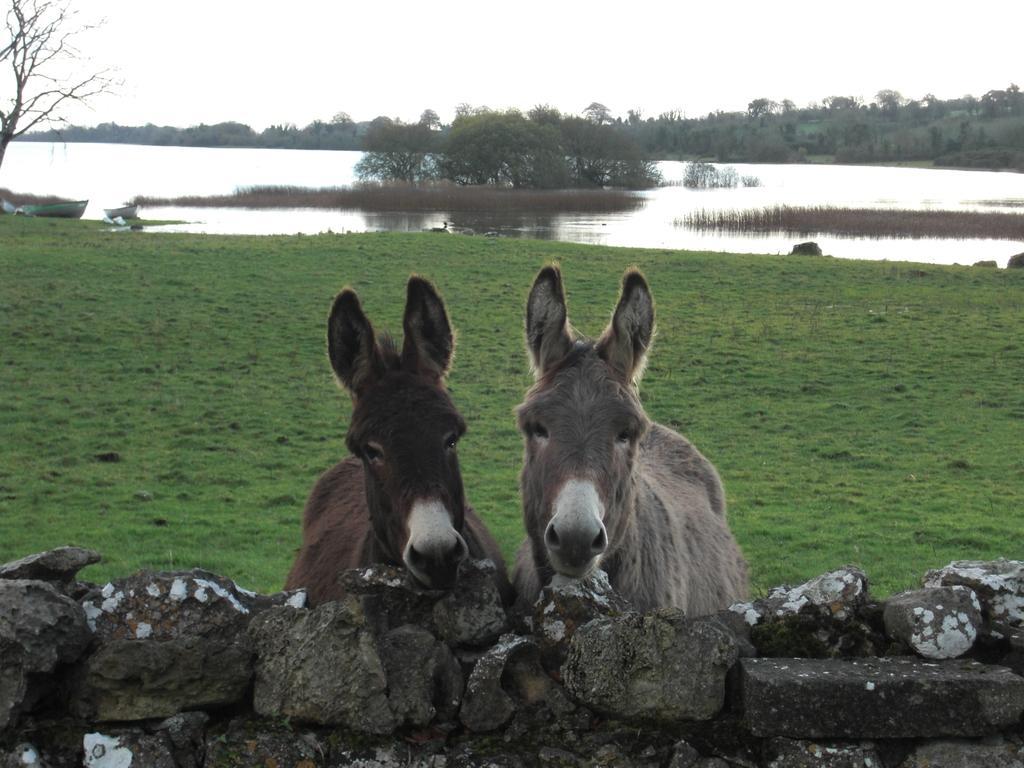Could you give a brief overview of what you see in this image? In this image we can see two animals, there is a wall, rocks, there are trees, also we can see the lake and the sky. 